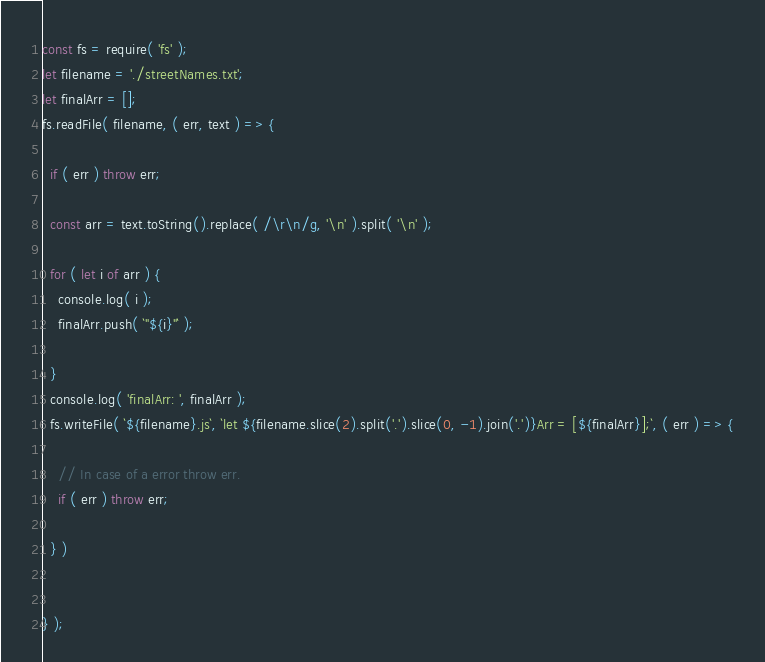<code> <loc_0><loc_0><loc_500><loc_500><_JavaScript_>const fs = require( 'fs' );
let filename = './streetNames.txt';
let finalArr = [];
fs.readFile( filename, ( err, text ) => {

  if ( err ) throw err;

  const arr = text.toString().replace( /\r\n/g, '\n' ).split( '\n' );

  for ( let i of arr ) {
    console.log( i );
    finalArr.push( `"${i}"` );

  }
  console.log( 'finalArr: ', finalArr );
  fs.writeFile( `${filename}.js`, `let ${filename.slice(2).split('.').slice(0, -1).join('.')}Arr = [${finalArr}];`, ( err ) => {

    // In case of a error throw err. 
    if ( err ) throw err;

  } )


} );
</code> 